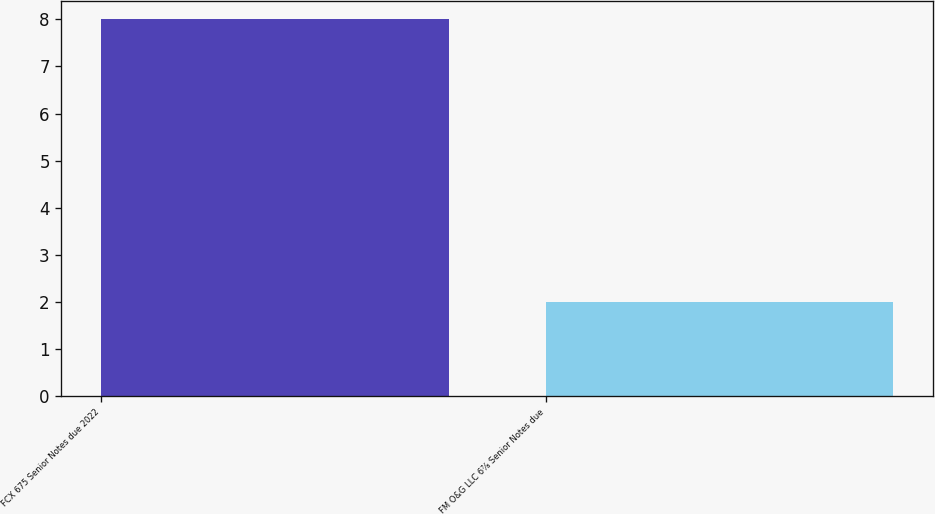Convert chart to OTSL. <chart><loc_0><loc_0><loc_500><loc_500><bar_chart><fcel>FCX 675 Senior Notes due 2022<fcel>FM O&G LLC 6⅞ Senior Notes due<nl><fcel>8<fcel>2<nl></chart> 